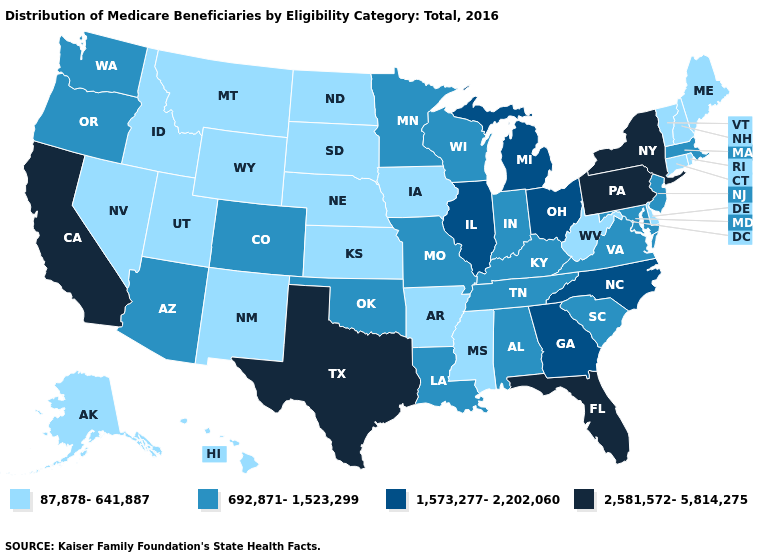What is the lowest value in states that border Arizona?
Be succinct. 87,878-641,887. Does New Jersey have the highest value in the Northeast?
Write a very short answer. No. Among the states that border South Dakota , which have the highest value?
Keep it brief. Minnesota. What is the highest value in states that border North Dakota?
Keep it brief. 692,871-1,523,299. Name the states that have a value in the range 87,878-641,887?
Answer briefly. Alaska, Arkansas, Connecticut, Delaware, Hawaii, Idaho, Iowa, Kansas, Maine, Mississippi, Montana, Nebraska, Nevada, New Hampshire, New Mexico, North Dakota, Rhode Island, South Dakota, Utah, Vermont, West Virginia, Wyoming. What is the lowest value in states that border Utah?
Keep it brief. 87,878-641,887. Which states hav the highest value in the Northeast?
Keep it brief. New York, Pennsylvania. Name the states that have a value in the range 2,581,572-5,814,275?
Quick response, please. California, Florida, New York, Pennsylvania, Texas. What is the value of Michigan?
Short answer required. 1,573,277-2,202,060. What is the value of Connecticut?
Concise answer only. 87,878-641,887. Name the states that have a value in the range 1,573,277-2,202,060?
Write a very short answer. Georgia, Illinois, Michigan, North Carolina, Ohio. What is the highest value in the USA?
Give a very brief answer. 2,581,572-5,814,275. Which states have the lowest value in the USA?
Short answer required. Alaska, Arkansas, Connecticut, Delaware, Hawaii, Idaho, Iowa, Kansas, Maine, Mississippi, Montana, Nebraska, Nevada, New Hampshire, New Mexico, North Dakota, Rhode Island, South Dakota, Utah, Vermont, West Virginia, Wyoming. Name the states that have a value in the range 692,871-1,523,299?
Be succinct. Alabama, Arizona, Colorado, Indiana, Kentucky, Louisiana, Maryland, Massachusetts, Minnesota, Missouri, New Jersey, Oklahoma, Oregon, South Carolina, Tennessee, Virginia, Washington, Wisconsin. How many symbols are there in the legend?
Keep it brief. 4. 